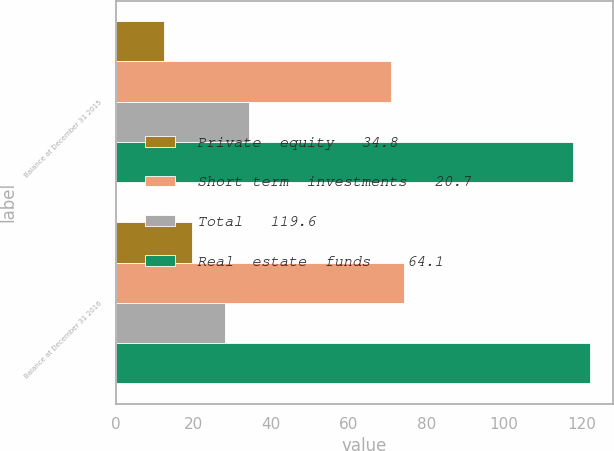<chart> <loc_0><loc_0><loc_500><loc_500><stacked_bar_chart><ecel><fcel>Balance at December 31 2015<fcel>Balance at December 31 2016<nl><fcel>Private  equity   34.8<fcel>12.4<fcel>19.7<nl><fcel>Short term  investments   20.7<fcel>70.9<fcel>74.3<nl><fcel>Total   119.6<fcel>34.3<fcel>28<nl><fcel>Real  estate  funds    64.1<fcel>117.6<fcel>122<nl></chart> 